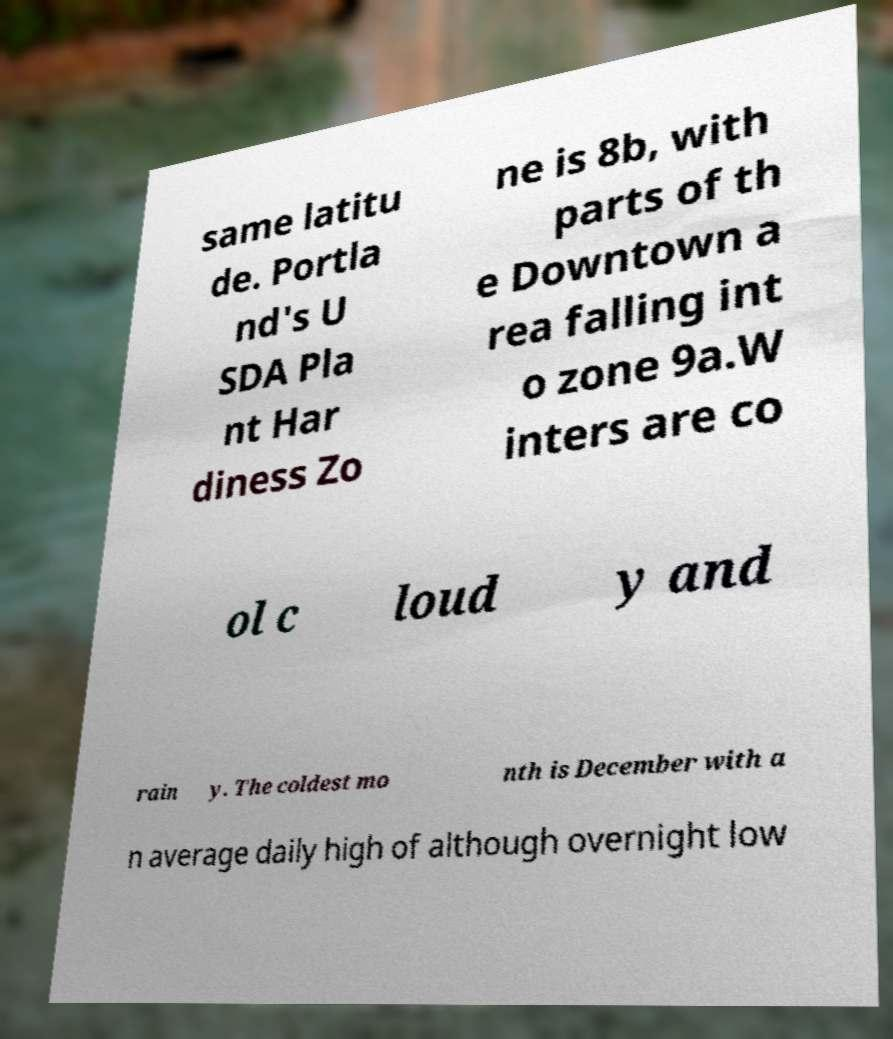There's text embedded in this image that I need extracted. Can you transcribe it verbatim? same latitu de. Portla nd's U SDA Pla nt Har diness Zo ne is 8b, with parts of th e Downtown a rea falling int o zone 9a.W inters are co ol c loud y and rain y. The coldest mo nth is December with a n average daily high of although overnight low 